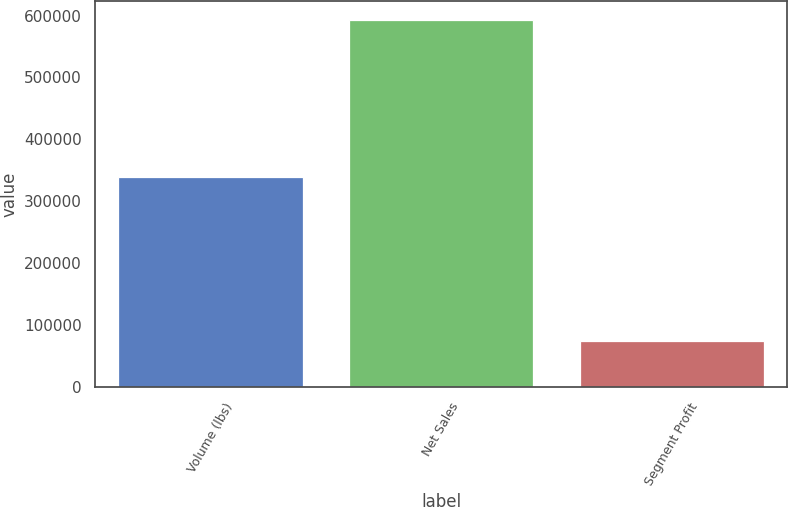Convert chart to OTSL. <chart><loc_0><loc_0><loc_500><loc_500><bar_chart><fcel>Volume (lbs)<fcel>Net Sales<fcel>Segment Profit<nl><fcel>339296<fcel>593476<fcel>75513<nl></chart> 